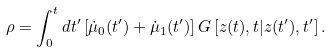<formula> <loc_0><loc_0><loc_500><loc_500>\rho = \int _ { 0 } ^ { t } d t ^ { \prime } \left [ \dot { \mu } _ { 0 } ( t ^ { \prime } ) + \dot { \mu } _ { 1 } ( t ^ { \prime } ) \right ] G \left [ z ( t ) , t | z ( t ^ { \prime } ) , t ^ { \prime } \right ] .</formula> 